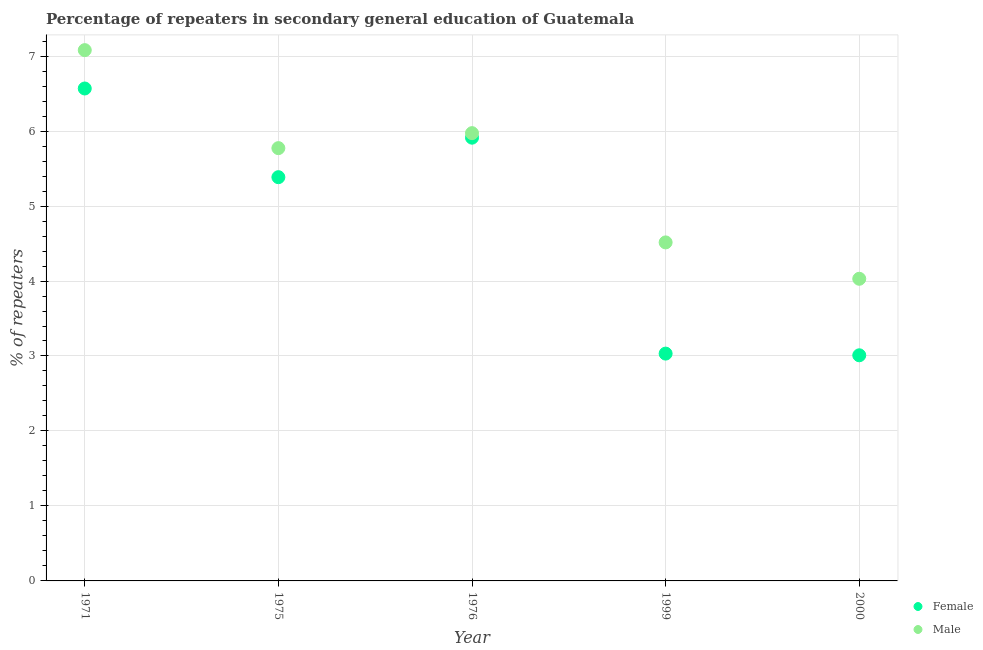What is the percentage of female repeaters in 1975?
Keep it short and to the point. 5.38. Across all years, what is the maximum percentage of female repeaters?
Keep it short and to the point. 6.57. Across all years, what is the minimum percentage of male repeaters?
Your answer should be very brief. 4.03. In which year was the percentage of male repeaters maximum?
Your response must be concise. 1971. In which year was the percentage of female repeaters minimum?
Your answer should be very brief. 2000. What is the total percentage of female repeaters in the graph?
Keep it short and to the point. 23.91. What is the difference between the percentage of male repeaters in 1976 and that in 1999?
Provide a short and direct response. 1.46. What is the difference between the percentage of female repeaters in 1999 and the percentage of male repeaters in 1971?
Provide a succinct answer. -4.05. What is the average percentage of female repeaters per year?
Offer a terse response. 4.78. In the year 2000, what is the difference between the percentage of female repeaters and percentage of male repeaters?
Offer a terse response. -1.02. What is the ratio of the percentage of female repeaters in 1999 to that in 2000?
Ensure brevity in your answer.  1.01. Is the percentage of female repeaters in 1976 less than that in 1999?
Make the answer very short. No. What is the difference between the highest and the second highest percentage of male repeaters?
Give a very brief answer. 1.11. What is the difference between the highest and the lowest percentage of male repeaters?
Ensure brevity in your answer.  3.05. Is the sum of the percentage of female repeaters in 1971 and 1976 greater than the maximum percentage of male repeaters across all years?
Provide a succinct answer. Yes. Does the percentage of male repeaters monotonically increase over the years?
Ensure brevity in your answer.  No. Is the percentage of female repeaters strictly greater than the percentage of male repeaters over the years?
Your answer should be compact. No. What is the difference between two consecutive major ticks on the Y-axis?
Offer a very short reply. 1. How are the legend labels stacked?
Your response must be concise. Vertical. What is the title of the graph?
Offer a terse response. Percentage of repeaters in secondary general education of Guatemala. Does "Start a business" appear as one of the legend labels in the graph?
Ensure brevity in your answer.  No. What is the label or title of the X-axis?
Your response must be concise. Year. What is the label or title of the Y-axis?
Make the answer very short. % of repeaters. What is the % of repeaters of Female in 1971?
Your answer should be very brief. 6.57. What is the % of repeaters of Male in 1971?
Your answer should be very brief. 7.08. What is the % of repeaters of Female in 1975?
Ensure brevity in your answer.  5.38. What is the % of repeaters in Male in 1975?
Offer a very short reply. 5.77. What is the % of repeaters in Female in 1976?
Provide a short and direct response. 5.91. What is the % of repeaters in Male in 1976?
Keep it short and to the point. 5.97. What is the % of repeaters in Female in 1999?
Your answer should be very brief. 3.03. What is the % of repeaters of Male in 1999?
Offer a terse response. 4.51. What is the % of repeaters in Female in 2000?
Offer a very short reply. 3.01. What is the % of repeaters of Male in 2000?
Your answer should be compact. 4.03. Across all years, what is the maximum % of repeaters of Female?
Offer a terse response. 6.57. Across all years, what is the maximum % of repeaters in Male?
Your answer should be very brief. 7.08. Across all years, what is the minimum % of repeaters of Female?
Ensure brevity in your answer.  3.01. Across all years, what is the minimum % of repeaters of Male?
Provide a short and direct response. 4.03. What is the total % of repeaters in Female in the graph?
Ensure brevity in your answer.  23.91. What is the total % of repeaters in Male in the graph?
Your response must be concise. 27.37. What is the difference between the % of repeaters in Female in 1971 and that in 1975?
Offer a very short reply. 1.18. What is the difference between the % of repeaters in Male in 1971 and that in 1975?
Ensure brevity in your answer.  1.31. What is the difference between the % of repeaters in Female in 1971 and that in 1976?
Give a very brief answer. 0.66. What is the difference between the % of repeaters in Male in 1971 and that in 1976?
Your answer should be very brief. 1.11. What is the difference between the % of repeaters of Female in 1971 and that in 1999?
Offer a terse response. 3.54. What is the difference between the % of repeaters in Male in 1971 and that in 1999?
Keep it short and to the point. 2.56. What is the difference between the % of repeaters in Female in 1971 and that in 2000?
Give a very brief answer. 3.56. What is the difference between the % of repeaters of Male in 1971 and that in 2000?
Make the answer very short. 3.05. What is the difference between the % of repeaters in Female in 1975 and that in 1976?
Ensure brevity in your answer.  -0.53. What is the difference between the % of repeaters of Male in 1975 and that in 1976?
Your response must be concise. -0.2. What is the difference between the % of repeaters in Female in 1975 and that in 1999?
Give a very brief answer. 2.35. What is the difference between the % of repeaters in Male in 1975 and that in 1999?
Keep it short and to the point. 1.26. What is the difference between the % of repeaters of Female in 1975 and that in 2000?
Give a very brief answer. 2.38. What is the difference between the % of repeaters in Male in 1975 and that in 2000?
Offer a very short reply. 1.74. What is the difference between the % of repeaters in Female in 1976 and that in 1999?
Your response must be concise. 2.88. What is the difference between the % of repeaters of Male in 1976 and that in 1999?
Ensure brevity in your answer.  1.46. What is the difference between the % of repeaters in Female in 1976 and that in 2000?
Offer a terse response. 2.9. What is the difference between the % of repeaters in Male in 1976 and that in 2000?
Your answer should be compact. 1.94. What is the difference between the % of repeaters in Female in 1999 and that in 2000?
Provide a short and direct response. 0.02. What is the difference between the % of repeaters in Male in 1999 and that in 2000?
Provide a short and direct response. 0.49. What is the difference between the % of repeaters of Female in 1971 and the % of repeaters of Male in 1975?
Keep it short and to the point. 0.8. What is the difference between the % of repeaters of Female in 1971 and the % of repeaters of Male in 1976?
Keep it short and to the point. 0.6. What is the difference between the % of repeaters of Female in 1971 and the % of repeaters of Male in 1999?
Your response must be concise. 2.05. What is the difference between the % of repeaters in Female in 1971 and the % of repeaters in Male in 2000?
Provide a short and direct response. 2.54. What is the difference between the % of repeaters of Female in 1975 and the % of repeaters of Male in 1976?
Keep it short and to the point. -0.59. What is the difference between the % of repeaters in Female in 1975 and the % of repeaters in Male in 1999?
Give a very brief answer. 0.87. What is the difference between the % of repeaters in Female in 1975 and the % of repeaters in Male in 2000?
Your answer should be compact. 1.35. What is the difference between the % of repeaters in Female in 1976 and the % of repeaters in Male in 1999?
Offer a very short reply. 1.4. What is the difference between the % of repeaters in Female in 1976 and the % of repeaters in Male in 2000?
Offer a terse response. 1.88. What is the difference between the % of repeaters of Female in 1999 and the % of repeaters of Male in 2000?
Make the answer very short. -1. What is the average % of repeaters of Female per year?
Ensure brevity in your answer.  4.78. What is the average % of repeaters of Male per year?
Offer a very short reply. 5.47. In the year 1971, what is the difference between the % of repeaters of Female and % of repeaters of Male?
Make the answer very short. -0.51. In the year 1975, what is the difference between the % of repeaters of Female and % of repeaters of Male?
Offer a very short reply. -0.39. In the year 1976, what is the difference between the % of repeaters of Female and % of repeaters of Male?
Provide a short and direct response. -0.06. In the year 1999, what is the difference between the % of repeaters in Female and % of repeaters in Male?
Your answer should be compact. -1.48. In the year 2000, what is the difference between the % of repeaters in Female and % of repeaters in Male?
Your answer should be very brief. -1.02. What is the ratio of the % of repeaters of Female in 1971 to that in 1975?
Offer a terse response. 1.22. What is the ratio of the % of repeaters of Male in 1971 to that in 1975?
Make the answer very short. 1.23. What is the ratio of the % of repeaters in Female in 1971 to that in 1976?
Ensure brevity in your answer.  1.11. What is the ratio of the % of repeaters in Male in 1971 to that in 1976?
Your answer should be compact. 1.19. What is the ratio of the % of repeaters of Female in 1971 to that in 1999?
Provide a short and direct response. 2.17. What is the ratio of the % of repeaters in Male in 1971 to that in 1999?
Ensure brevity in your answer.  1.57. What is the ratio of the % of repeaters of Female in 1971 to that in 2000?
Make the answer very short. 2.18. What is the ratio of the % of repeaters of Male in 1971 to that in 2000?
Ensure brevity in your answer.  1.76. What is the ratio of the % of repeaters of Female in 1975 to that in 1976?
Give a very brief answer. 0.91. What is the ratio of the % of repeaters in Male in 1975 to that in 1976?
Keep it short and to the point. 0.97. What is the ratio of the % of repeaters of Female in 1975 to that in 1999?
Your answer should be compact. 1.78. What is the ratio of the % of repeaters in Male in 1975 to that in 1999?
Keep it short and to the point. 1.28. What is the ratio of the % of repeaters of Female in 1975 to that in 2000?
Your answer should be compact. 1.79. What is the ratio of the % of repeaters in Male in 1975 to that in 2000?
Offer a very short reply. 1.43. What is the ratio of the % of repeaters in Female in 1976 to that in 1999?
Offer a terse response. 1.95. What is the ratio of the % of repeaters in Male in 1976 to that in 1999?
Your answer should be very brief. 1.32. What is the ratio of the % of repeaters of Female in 1976 to that in 2000?
Ensure brevity in your answer.  1.96. What is the ratio of the % of repeaters in Male in 1976 to that in 2000?
Provide a short and direct response. 1.48. What is the ratio of the % of repeaters in Female in 1999 to that in 2000?
Ensure brevity in your answer.  1.01. What is the ratio of the % of repeaters of Male in 1999 to that in 2000?
Offer a terse response. 1.12. What is the difference between the highest and the second highest % of repeaters of Female?
Provide a short and direct response. 0.66. What is the difference between the highest and the second highest % of repeaters in Male?
Your response must be concise. 1.11. What is the difference between the highest and the lowest % of repeaters of Female?
Offer a terse response. 3.56. What is the difference between the highest and the lowest % of repeaters of Male?
Keep it short and to the point. 3.05. 